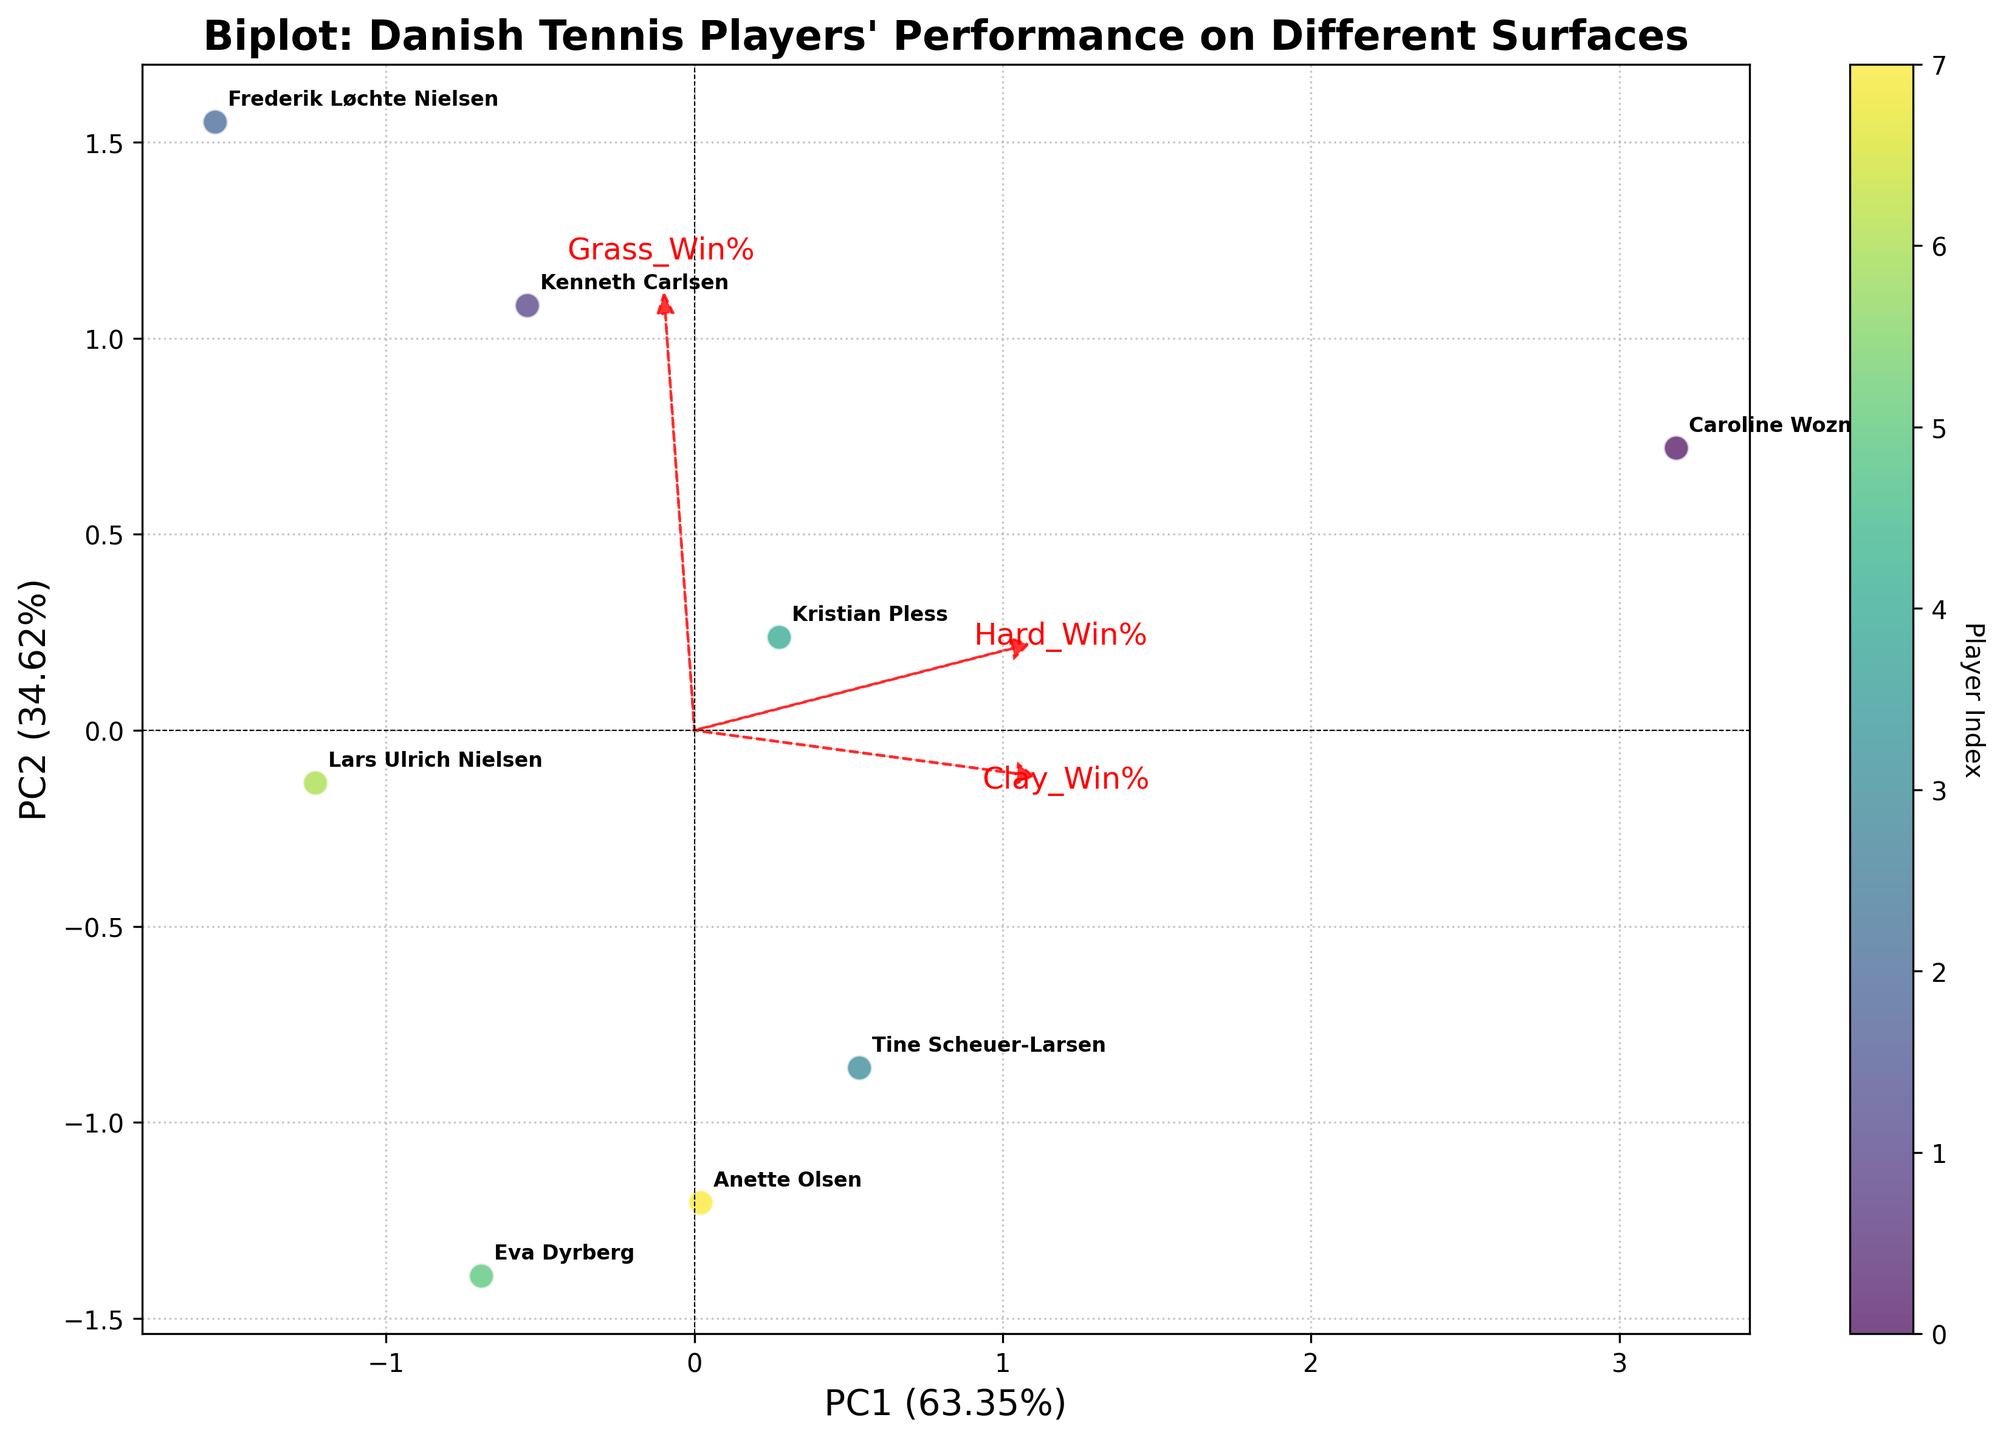Which player has the highest percentage win on hard courts? Looking at the axis labels for the player names and comparing the values of hard win percentages in the corresponding loading direction, Caroline Wozniacki is positioned furthest in the direction of the Hard Win% load.
Answer: Caroline Wozniacki What are the axes' labels indicating in this biplot? The x-axis indicates the first principal component (PC1) which accounts for the largest variance in the data, and the y-axis indicates the second principal component (PC2) which accounts for the second-largest variance. The labels also include the percentage variance explained by each component.
Answer: PC1 and PC2 with explained variance percentages Which surface type seems to be less important in differentiating players based on the loadings? By observing the lengths and angles of the loadings relative to the axes, the Grass Win% loading arrow is less prominently separated from the PC1 and PC2 axes compared to Clay Win% and Hard Win% loadings.
Answer: Grass Win% Between Caroline Wozniacki and Kenneth Carlsen, who appears to have a performance more influenced by the first principal component? Caroline Wozniacki is more separated along the x-axis direction (PC1) compared to Kenneth Carlsen, indicating her performance is represented more by PC1.
Answer: Caroline Wozniacki What is the biplot primarily indicating about Frederik Løchte Nielsen's performance on different surfaces? Frederik Løchte Nielsen's point is positioned strongly in the direction of the Grass Win% loading, indicating that his performance is significantly differentiated on grass courts.
Answer: Performance on grass courts Which two players are closest to each other in terms of their performance on the different surfaces? Comparing the proximity of the points, Tine Scheuer-Larsen and Kristian Pless are positioned close to each other on the biplot, suggesting they have similar performance across the surfaces.
Answer: Tine Scheuer-Larsen and Kristian Pless How does the plot visually indicate the variance explained by each principal component? The plot labels the x-axis and y-axis with their corresponding principal components (PC1 and PC2) along with the percentage of variance they each explain, visible in parentheses.
Answer: Labeled with percentages What is signified by the direction of the Clay Win% loading arrow? The direction of the Clay Win% loading arrow shows how much the win percentage on clay contributes to the players’ performance in relation to the first and second principal components, pointing towards where higher clay win percentages would lie.
Answer: Contribution to PC1 and PC2 Which player shows the lowest performance across all surface types based on the biplot? Considering the loading directions and the positions of the players, Eva Dyrberg is positioned towards the lower end of the plot, near lower performance direction indicators.
Answer: Eva Dyrberg What does the title of the biplot indicate about the focus of the analysis? The title "Biplot: Danish Tennis Players' Performance on Different Surfaces" specifies that the analysis focuses on comparing the performances of Danish players across clay, grass, and hard court surfaces.
Answer: Performance on different surfaces 